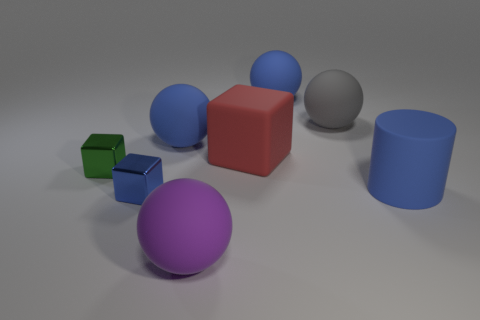What is the material of the blue cylinder that is the same size as the gray ball?
Offer a terse response. Rubber. How big is the ball on the left side of the big object that is in front of the large matte cylinder?
Your response must be concise. Large. Is the size of the sphere in front of the rubber block the same as the large gray matte ball?
Make the answer very short. Yes. Are there more big gray matte spheres that are behind the tiny green metal object than big purple balls that are on the right side of the red matte cube?
Ensure brevity in your answer.  Yes. There is a large object that is in front of the small green object and behind the purple rubber object; what is its shape?
Provide a short and direct response. Cylinder. There is a tiny metal object behind the blue rubber cylinder; what is its shape?
Provide a short and direct response. Cube. How big is the blue cube that is to the left of the large purple thing that is in front of the small blue object behind the big purple matte object?
Your response must be concise. Small. Is the green metal object the same shape as the big red matte thing?
Your answer should be very brief. Yes. What is the size of the rubber object that is both on the left side of the blue matte cylinder and in front of the red object?
Provide a succinct answer. Large. What is the material of the green thing that is the same shape as the blue metal thing?
Offer a very short reply. Metal. 